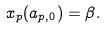Convert formula to latex. <formula><loc_0><loc_0><loc_500><loc_500>x _ { p } ( a _ { p , 0 } ) = \beta .</formula> 